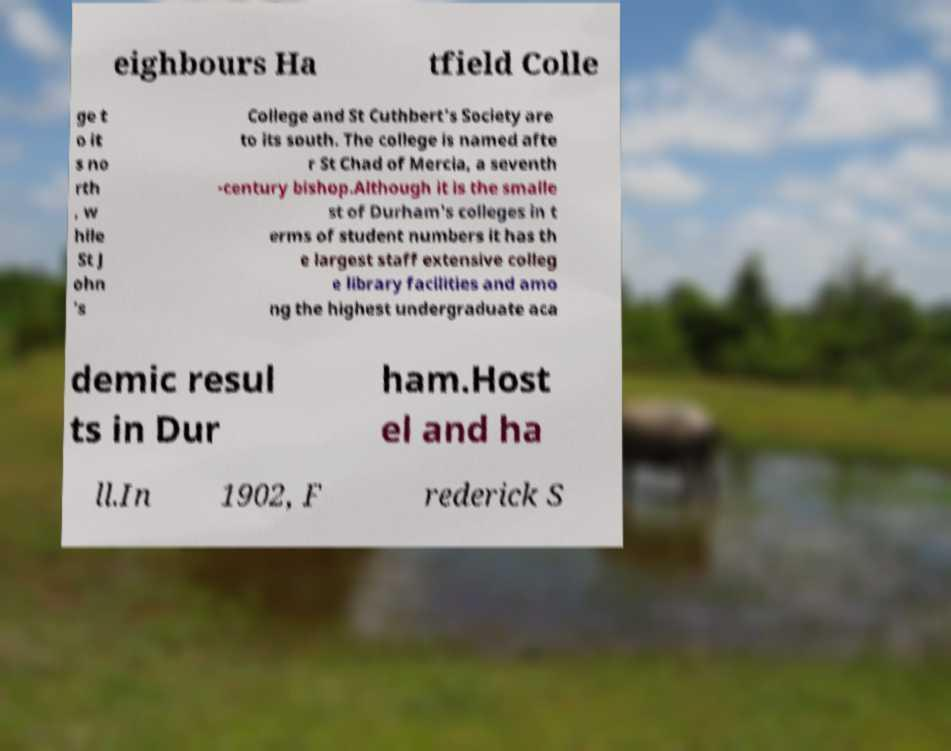Could you extract and type out the text from this image? eighbours Ha tfield Colle ge t o it s no rth , w hile St J ohn 's College and St Cuthbert's Society are to its south. The college is named afte r St Chad of Mercia, a seventh -century bishop.Although it is the smalle st of Durham's colleges in t erms of student numbers it has th e largest staff extensive colleg e library facilities and amo ng the highest undergraduate aca demic resul ts in Dur ham.Host el and ha ll.In 1902, F rederick S 